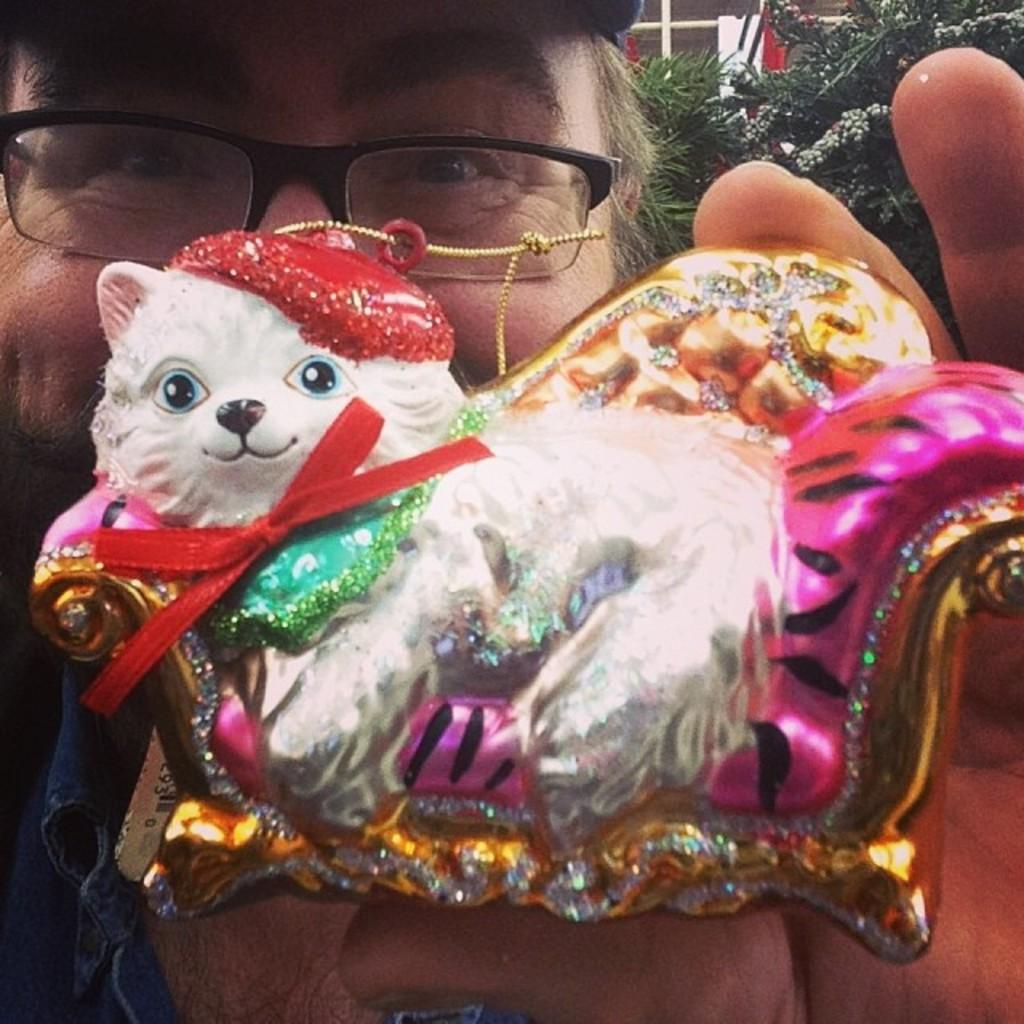Who or what is the main subject in the image? There is a person in the image. Can you describe the person's facial expression? The person's face is visible in the image. What is the person holding in their hand? The person is holding a doll in their hand. What type of vegetation can be seen in the image? There are plants visible in the image. How many stamps are on the person's forehead in the image? There are no stamps visible on the person's forehead in the image. What type of land can be seen in the background of the image? There is no reference to land or a background in the image; it primarily features a person holding a doll. 